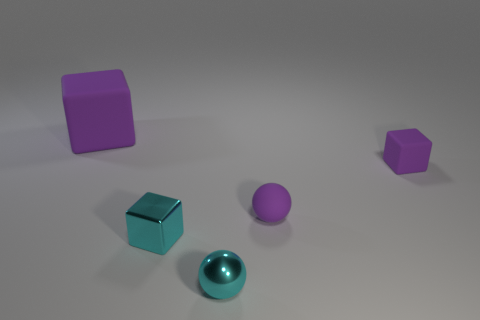How many purple blocks must be subtracted to get 1 purple blocks? 1 Subtract all small purple cubes. How many cubes are left? 2 Subtract all cubes. How many objects are left? 2 Add 5 cyan spheres. How many cyan spheres exist? 6 Add 1 red metal spheres. How many objects exist? 6 Subtract all purple cubes. How many cubes are left? 1 Subtract 0 brown balls. How many objects are left? 5 Subtract 1 cubes. How many cubes are left? 2 Subtract all red cubes. Subtract all blue cylinders. How many cubes are left? 3 Subtract all gray balls. How many red blocks are left? 0 